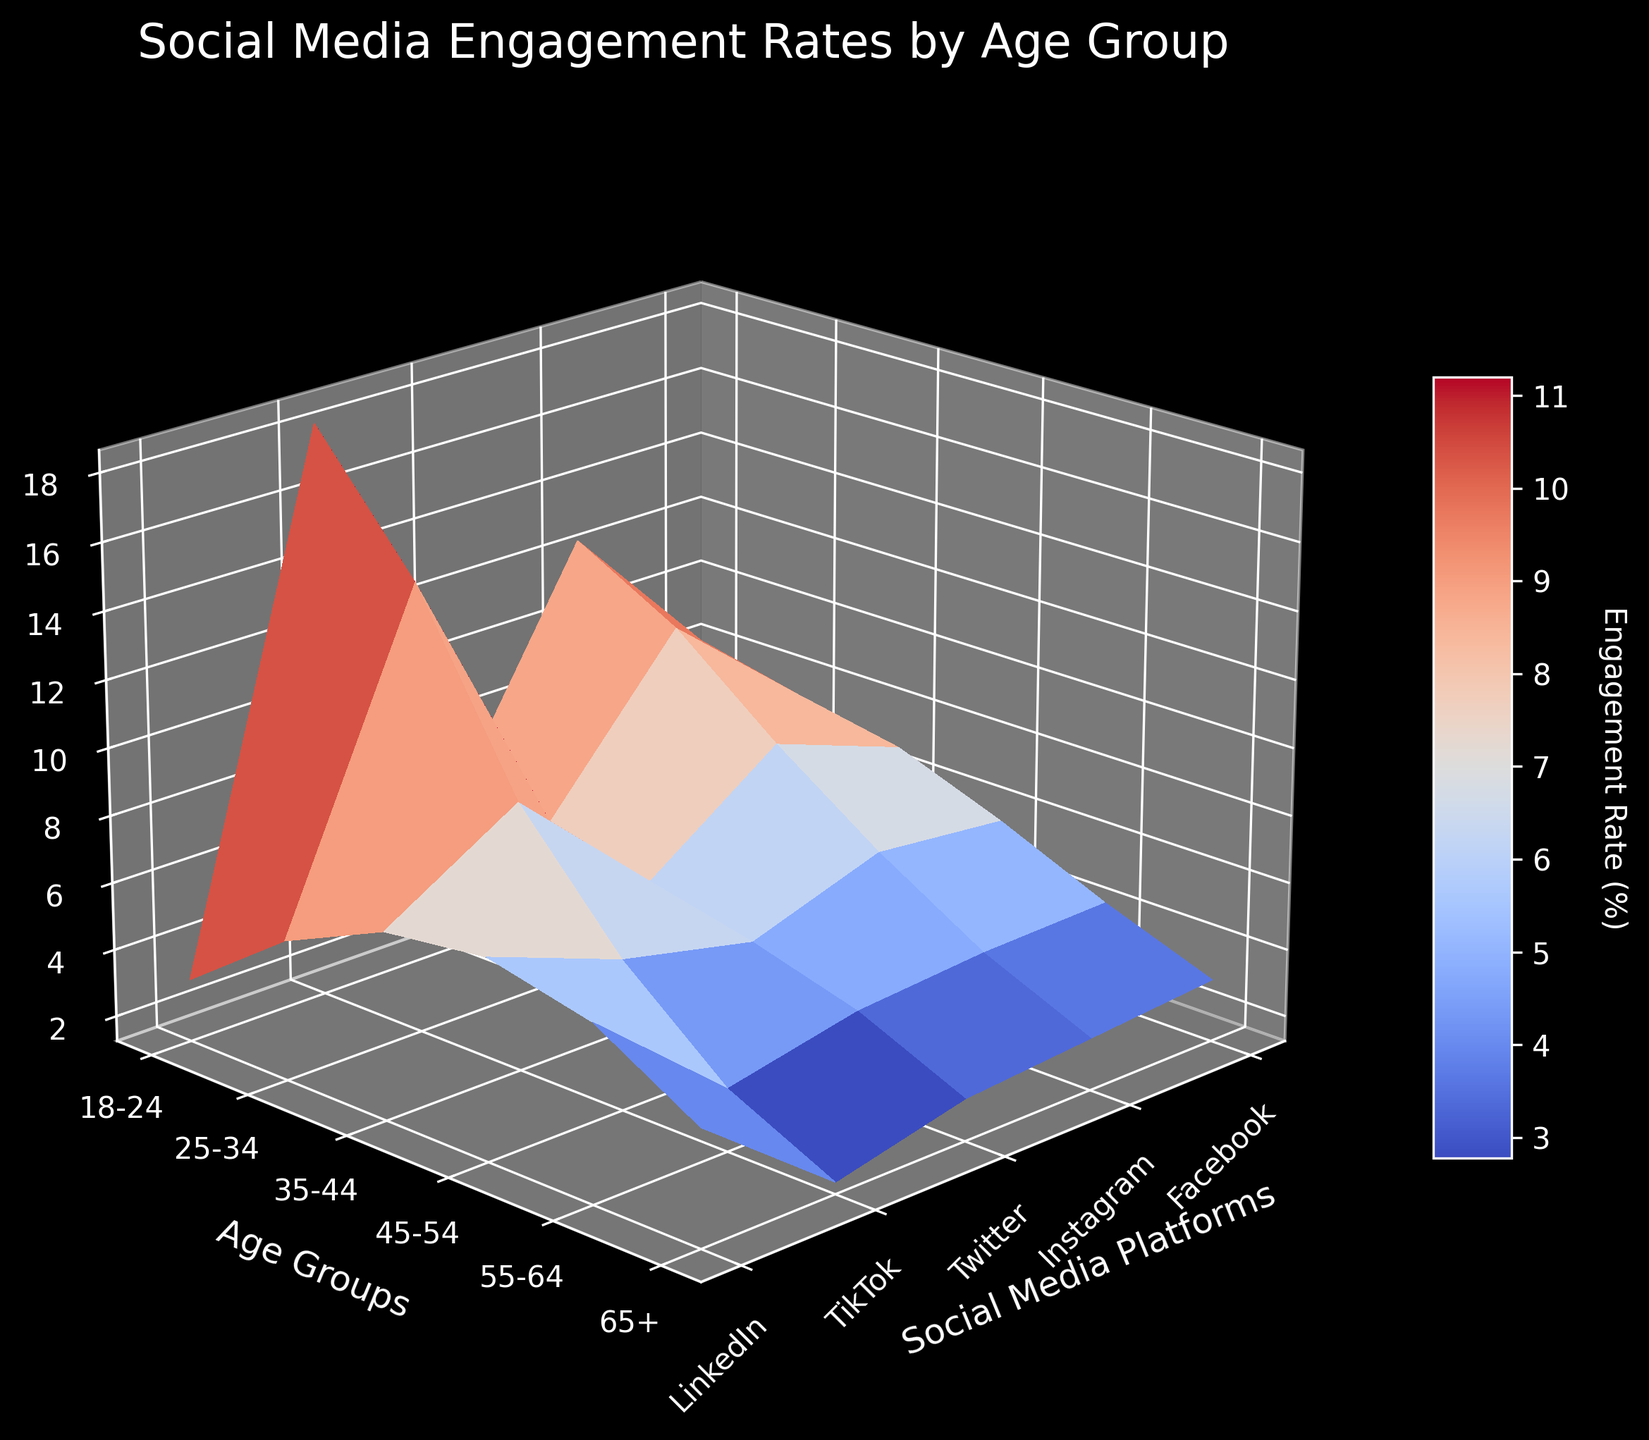What is the title of the plot? The title of the plot is displayed at the top of the figure. It provides an overview of what the plot is illustrating.
Answer: Social Media Engagement Rates by Age Group Which age group has the highest engagement rate on TikTok? By identifying the peak in the TikTok column (X-axis), you can find which Y-axis label (age group) corresponds to the highest Z value (engagement rate).
Answer: 18-24 What is the z-axis label of the plot? The z-axis label is located next to the axis that goes up and down in the 3D space and describes what the height of the surface represents.
Answer: Engagement Rate (%) How does the engagement rate of Instagram for the 25-34 age group compare to that of LinkedIn for the same group? By looking at the Y-axis value for the 25-34 age group and comparing the Z values for Instagram and LinkedIn, we can compare the engagement rates.
Answer: Instagram is higher than LinkedIn What are the units of measurement for the engagement rates in the plot? The units are detailed on the plot's z-axis label and the color bar next to the surface plot.
Answer: Percentage Which social media platform shows the most significant decrease in engagement rates as age increases? You need to examine the Z values from left to right for each age group on the Y-axis to see which platform declines the most.
Answer: TikTok Between which two age groups is the engagement rate difference for Facebook the greatest? Identify the Z-values for Facebook across age groups and calculate the differences, then find the two age groups with the maximum difference.
Answer: 18-24 and 65+ Based on the plot, which age group has the smallest engagement rate difference between Facebook and Twitter? Compare the differences in Z values for Facebook and Twitter across age groups to find the minimum.
Answer: 65+ How does the engagement rate for LinkedIn change from the 35-44 to the 45-54 age group? Examine the Z values for LinkedIn for the 35-44 and 45-54 age groups to see the change.
Answer: Increases What does the color bar represent in the plot? The color bar next to the 3D surface plot provides a visual representation of the engagement rates using different colors.
Answer: Engagement Rate (%) 